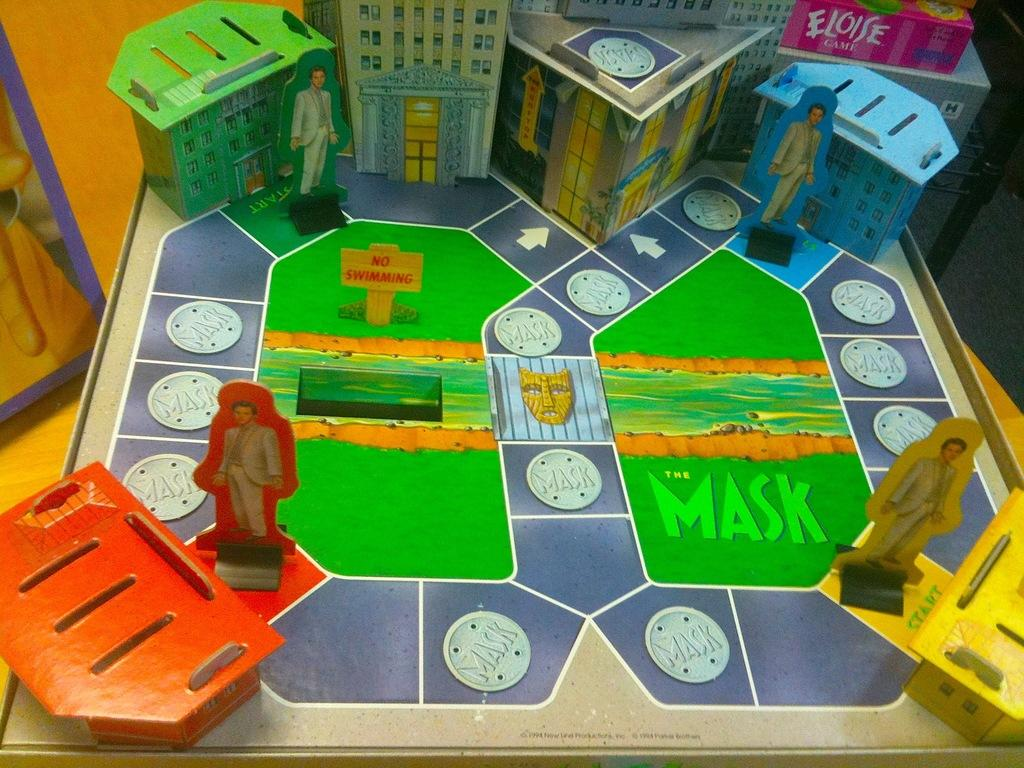What is the main object in the image? There is a game board in the image. Can you describe the game board? Unfortunately, the facts provided do not give any details about the game board's appearance or type of game. Is there anyone playing the game or interacting with the game board in the image? The facts provided do not mention any people or actions related to the game board. What type of pear is being used as a game piece in the image? There is no pear present in the image, as the only object mentioned is a game board. 